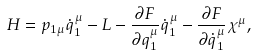<formula> <loc_0><loc_0><loc_500><loc_500>H = p _ { 1 \mu } \dot { q } _ { 1 } ^ { \mu } - L - \frac { \partial F } { \partial q _ { 1 } ^ { \mu } } \dot { q } _ { 1 } ^ { \mu } - \frac { \partial F } { \partial \dot { q } _ { 1 } ^ { \mu } } \chi ^ { \mu } ,</formula> 